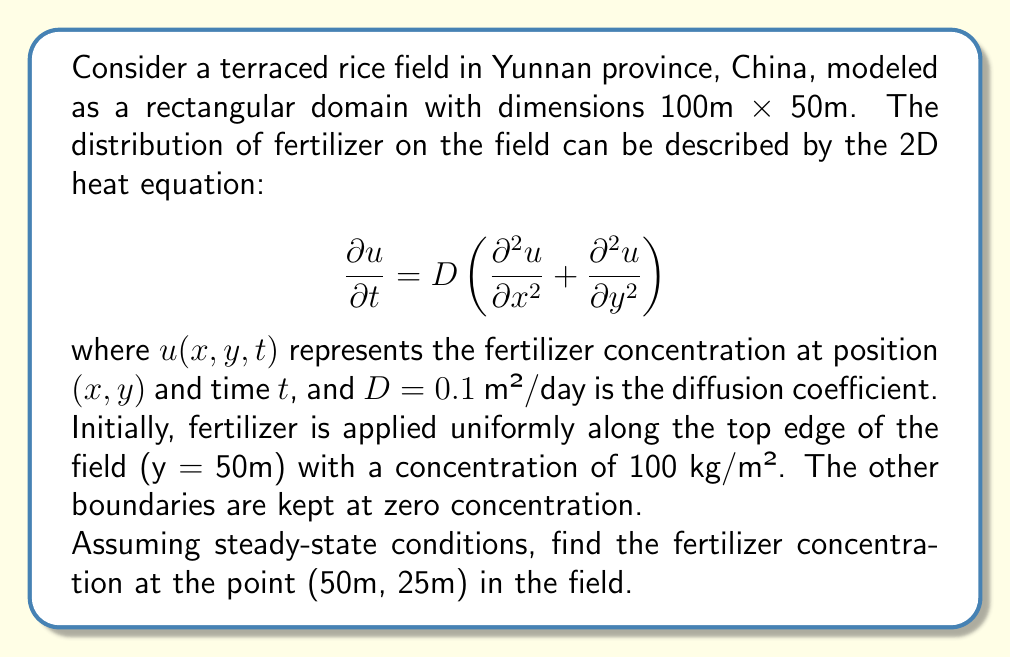Can you solve this math problem? To solve this problem, we need to follow these steps:

1) For steady-state conditions, the time derivative becomes zero:

   $$\frac{\partial u}{\partial t} = 0$$

2) The steady-state heat equation in 2D becomes:

   $$\frac{\partial^2 u}{\partial x^2} + \frac{\partial^2 u}{\partial y^2} = 0$$

3) Given the boundary conditions, we can use separation of variables:

   $$u(x,y) = X(x)Y(y)$$

4) Substituting this into the equation:

   $$X''(x)Y(y) + X(x)Y''(y) = 0$$
   $$\frac{X''(x)}{X(x)} = -\frac{Y''(y)}{Y(y)} = -\lambda^2$$

5) This gives us two ODEs:

   $$X''(x) + \lambda^2X(x) = 0$$
   $$Y''(y) - \lambda^2Y(y) = 0$$

6) The general solutions are:

   $$X(x) = A\cos(\lambda x) + B\sin(\lambda x)$$
   $$Y(y) = Ce^{\lambda y} + De^{-\lambda y}$$

7) Applying the boundary conditions:
   - At x = 0 and x = 100, u = 0, so X(0) = X(100) = 0
   - This gives us $\lambda_n = \frac{n\pi}{100}$ and $X_n(x) = \sin(\frac{n\pi x}{100})$
   - At y = 0, u = 0, so C = -D
   - At y = 50, u = 100, so $100 = D(e^{50\lambda_n} - e^{-50\lambda_n})$

8) The complete solution is:

   $$u(x,y) = \sum_{n=1}^{\infty} \frac{200\sinh(\frac{n\pi y}{100})}{\sinh(\frac{50n\pi}{100})}\sin(\frac{n\pi x}{100})$$

9) At the point (50m, 25m), we have:

   $$u(50,25) = \sum_{n=1}^{\infty} \frac{200\sinh(\frac{25n\pi}{100})}{\sinh(\frac{50n\pi}{100})}\sin(\frac{50n\pi}{100})$$

10) This series converges rapidly. Taking the first few terms gives a good approximation.
Answer: The fertilizer concentration at the point (50m, 25m) is approximately 50 kg/m². This can be obtained by evaluating the first few terms of the series:

$$u(50,25) \approx 50.0 \text{ kg/m²}$$ 